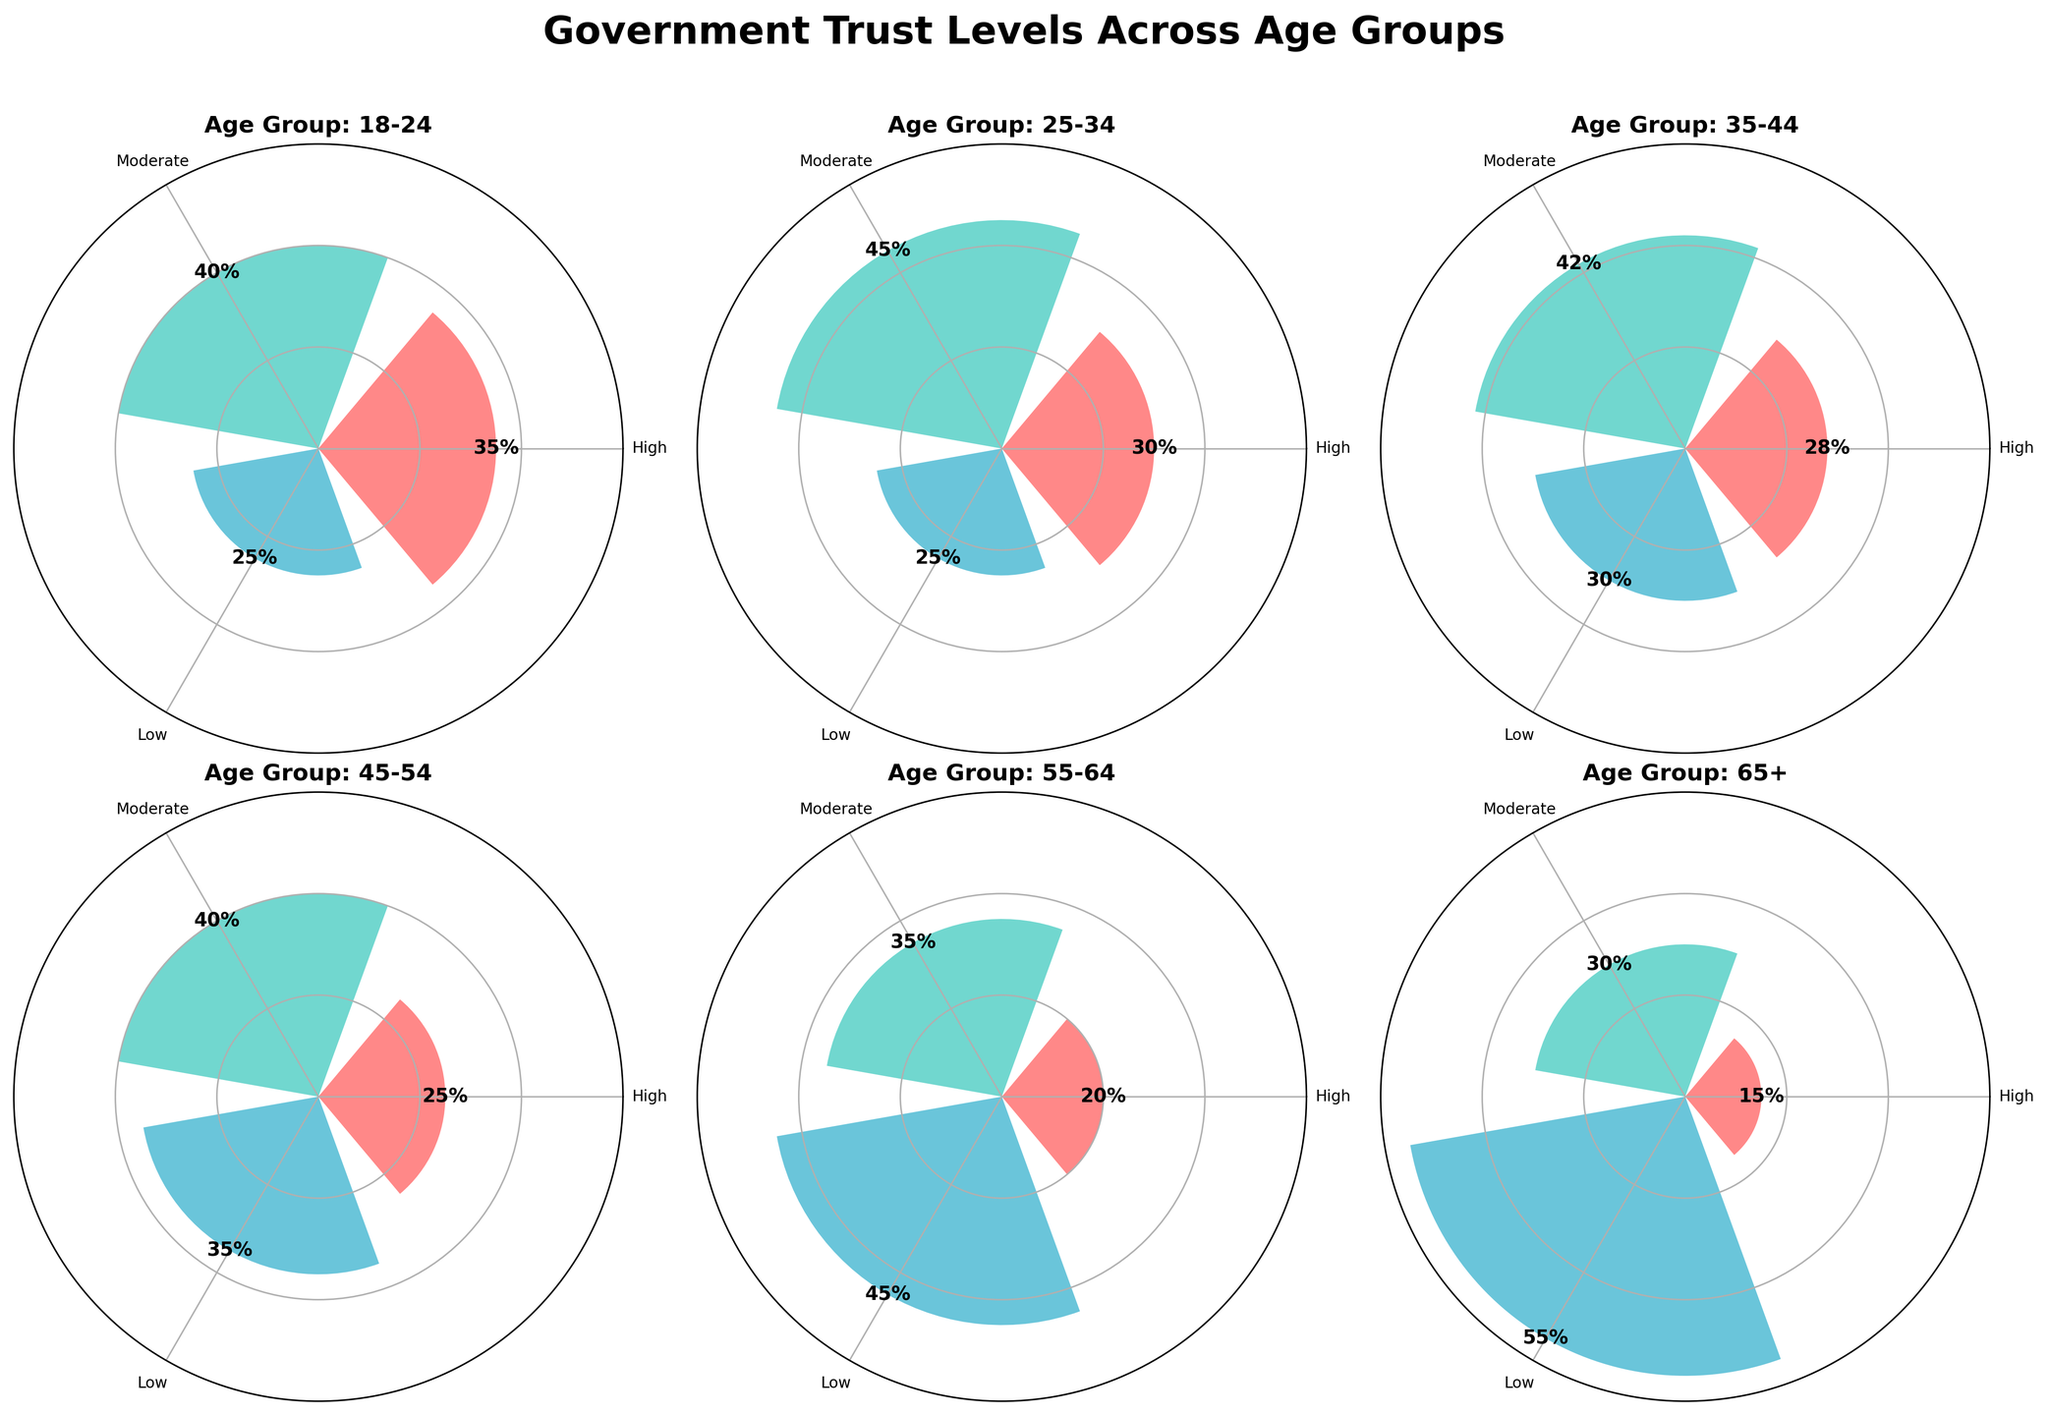Who has the highest level of trust in the government among all the age groups? The highest level of trust in the government is represented by the 'High' trust category. According to the plot, the age group 18-24 has the highest percentage in this category at 35%.
Answer: 18-24 In which age group do people have the least trust in the government? The least trust in the government is represented by the 'Low' trust category. The age group 65+ shows the highest percentage in this category at 55%.
Answer: 65+ How do the levels of trust in the government compare between the 25-34 and 55-64 age groups? The 'High' trust level in the 25-34 age group is at 30%, while in the 55-64 age group it is at 20%. For 'Moderate' trust, 25-34 is at 45% and 55-64 is at 35%. For 'Low' trust, 25-34 is at 25% and 55-64 is at 45%.
Answer: 25-34 shows more trust What is the total percentage of people who trust the government at 'High' or 'Moderate' levels in the 45-54 age group? Add the percentages of 'High' and 'Moderate' trust levels in the 45-54 age group: 25% (High) + 40% (Moderate) = 65%.
Answer: 65% In which age group is the percentage of 'Moderate' trust closest to the average percentage of 'Moderate' trust levels across all age groups? First, calculate the average percentage of 'Moderate' trust levels. The values are: 40%, 45%, 42%, 40%, 35%, 30%. The average is (40+45+42+40+35+30)/6 = 38.67%. The closest percentage to this average is in the 35-44 age group with 42%.
Answer: 35-44 How does the 'Low' level of trust in the 35-44 age group compare to those in the 18-24 and 55-64 age groups? The 'Low' trust level in the 35-44 age group is 30%. In the 18-24 age group, it is 25%, and in the 55-64 age group, it is 45%. Therefore, 35-44 is higher than 18-24 but lower than 55-64.
Answer: Between 18-24 and 55-64 Which age group has the smallest range between the highest and lowest trust levels? For each age group, the range is calculated by subtracting the smallest percentage from the largest percentage. The ranges are: 18-24 (40-25 = 15), 25-34 (45-25 = 20), 35-44 (42-28 = 14), 45-54 (40-25 = 15), 55-64 (45-20 = 25), 65+ (55-15 = 40). The 35-44 age group has the smallest range (14).
Answer: 35-44 What trend do we observe in the 'High' level of trust as the age groups progress from 18-24 to 65+? By observing the 'High' trust level percentages across the age groups 18-24 (35%), 25-34 (30%), 35-44 (28%), 45-54 (25%), 55-64 (20%), 65+ (15%), we see a decreasing trend in the 'High' level of trust as age increases.
Answer: Decreasing trend 